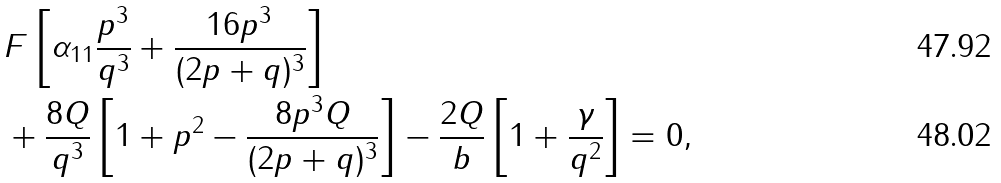Convert formula to latex. <formula><loc_0><loc_0><loc_500><loc_500>& F \left [ \alpha _ { 1 1 } \frac { p ^ { 3 } } { q ^ { 3 } } + \frac { 1 6 p ^ { 3 } } { ( 2 p + q ) ^ { 3 } } \right ] \\ & + \frac { 8 Q } { q ^ { 3 } } \left [ 1 + p ^ { 2 } - \frac { 8 p ^ { 3 } Q } { ( 2 p + q ) ^ { 3 } } \right ] - \frac { 2 Q } { b } \left [ 1 + \frac { \gamma } { q ^ { 2 } } \right ] = 0 ,</formula> 